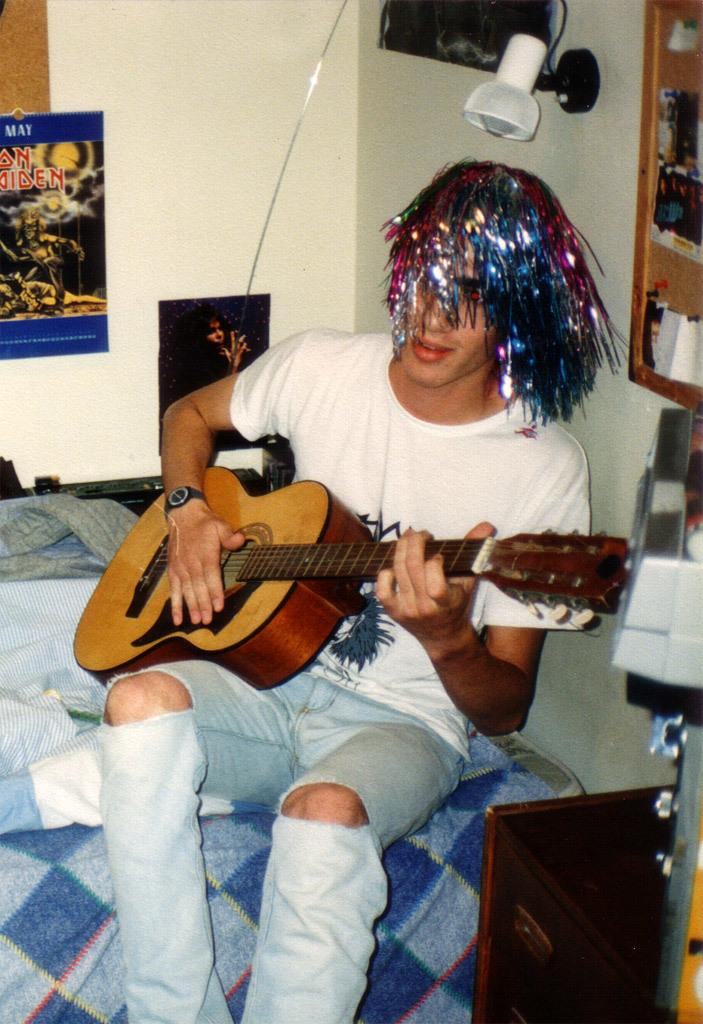What is the person in the image doing? The person is sitting on the bed. What object is the person holding? The person is holding a guitar. What can be seen on the wall in the image? There are frames on the wall. Can you describe the lighting source in the image? There is a lamp on the wall. What type of map can be seen on the wall in the image? There is no map present in the image; only frames and a lamp can be seen on the wall. What kind of stocking is the person wearing in the image? The person's clothing is not described in the image, so we cannot determine if they are wearing stockings or not. 